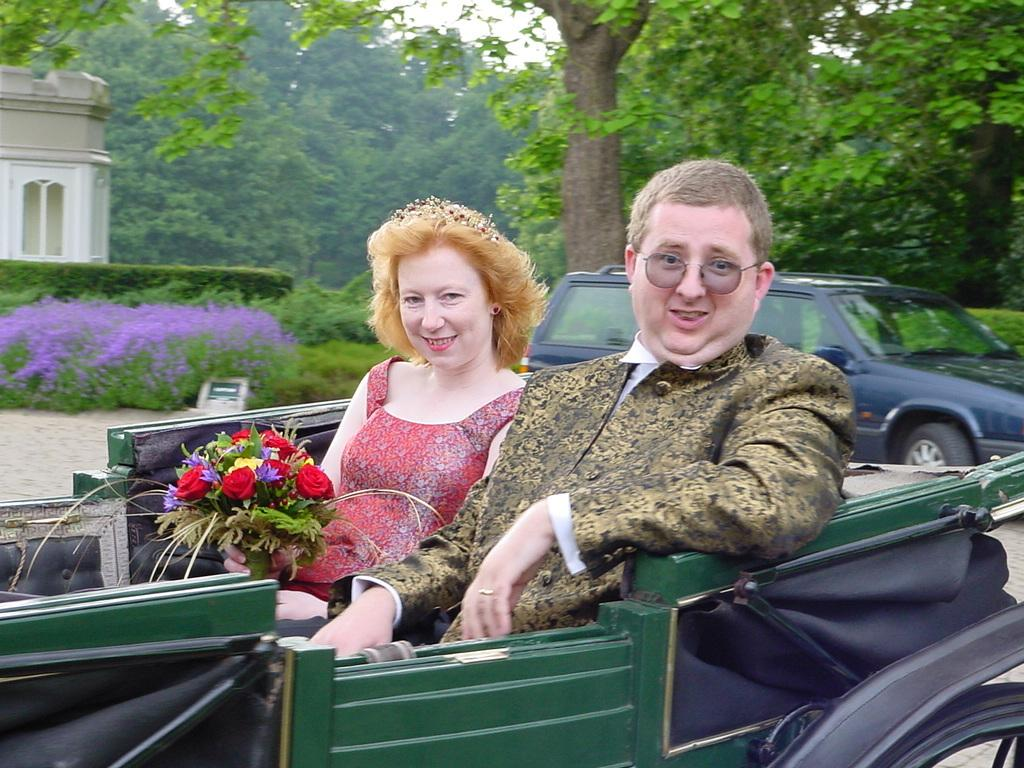How many people are present in the image? There are two people, a man and a woman, present in the image. What are the man and woman doing in the image? Both the man and woman are sitting in a car. What is happening in the background of the image? There is a car, a tree, a building, and plants in the background of the image. What is the woman in the image doing with the flower bouquet? The woman is catching a flower bouquet. What type of fork can be seen in the image? There is no fork present in the image. What type of vacation is the couple planning in the image? There is no indication of a vacation in the image; it simply shows a man and woman sitting in a car and a woman catching a flower bouquet. 